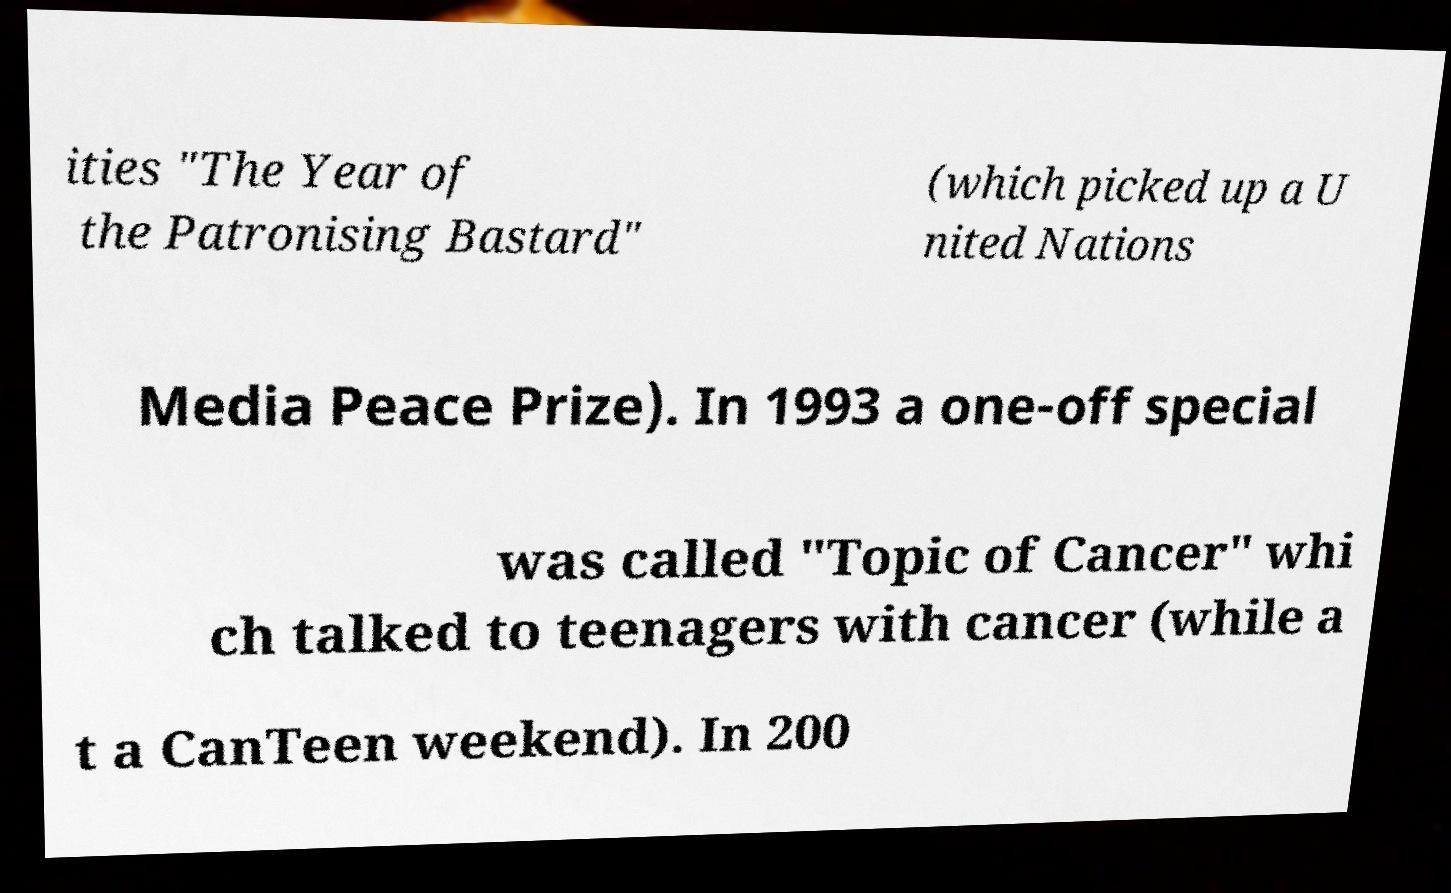I need the written content from this picture converted into text. Can you do that? ities "The Year of the Patronising Bastard" (which picked up a U nited Nations Media Peace Prize). In 1993 a one-off special was called "Topic of Cancer" whi ch talked to teenagers with cancer (while a t a CanTeen weekend). In 200 